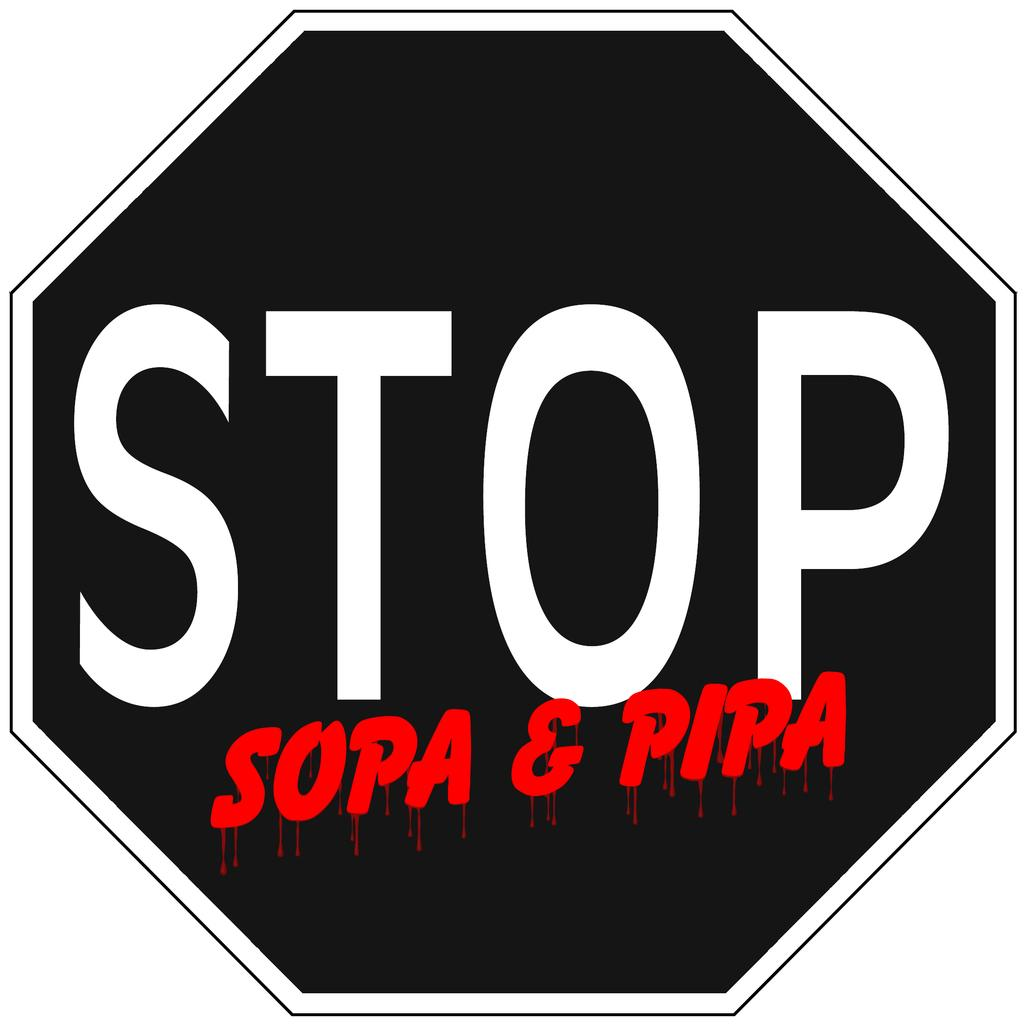<image>
Provide a brief description of the given image. a black octogon STOP sopa & pipa sign 